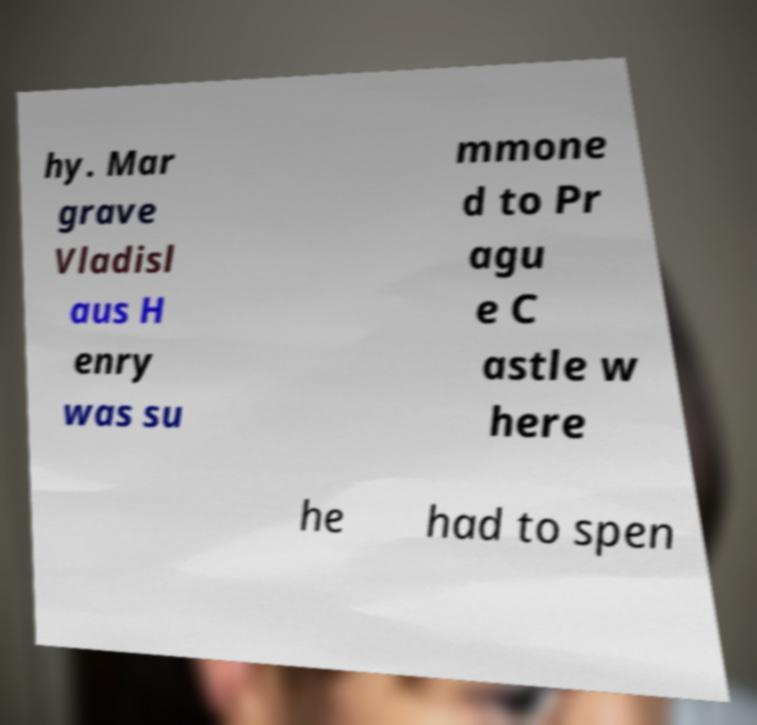Can you read and provide the text displayed in the image?This photo seems to have some interesting text. Can you extract and type it out for me? hy. Mar grave Vladisl aus H enry was su mmone d to Pr agu e C astle w here he had to spen 